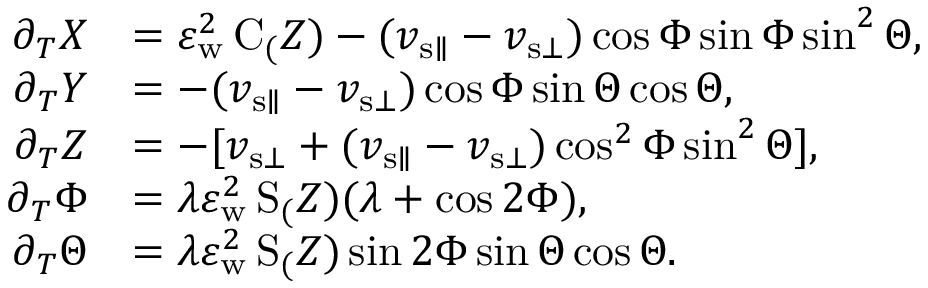Convert formula to latex. <formula><loc_0><loc_0><loc_500><loc_500>\begin{array} { r l } { \partial _ { T } X } & { = \varepsilon _ { w } ^ { 2 } \, C _ { ( } Z ) - ( v _ { { s } \| } - v _ { { s } \bot } ) \cos \Phi \sin \Phi \sin ^ { 2 } \Theta , } \\ { \partial _ { T } Y } & { = - ( v _ { { s } \| } - v _ { { s } \bot } ) \cos \Phi \sin \Theta \cos \Theta , } \\ { \partial _ { T } Z } & { = - [ v _ { { s } \bot } + ( v _ { { s } \| } - v _ { { s } \bot } ) \cos ^ { 2 } \Phi \sin ^ { 2 } \Theta ] , } \\ { \partial _ { T } \Phi } & { = \lambda \varepsilon _ { w } ^ { 2 } \, S _ { ( } Z ) ( \lambda + \cos 2 \Phi ) , } \\ { \partial _ { T } \Theta } & { = \lambda \varepsilon _ { w } ^ { 2 } \, S _ { ( } Z ) \sin 2 \Phi \sin \Theta \cos \Theta . } \end{array}</formula> 